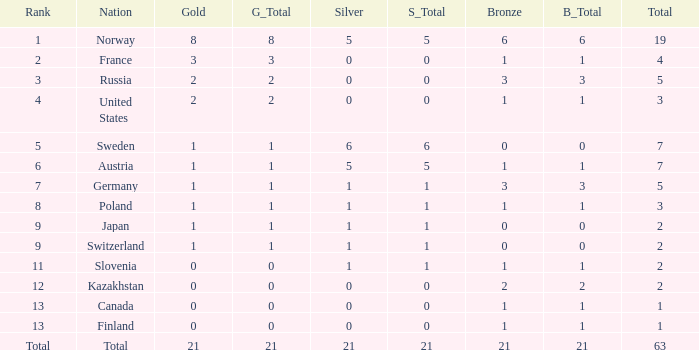What Rank has a gold smaller than 1, and a silver larger than 0? 11.0. Parse the full table. {'header': ['Rank', 'Nation', 'Gold', 'G_Total', 'Silver', 'S_Total', 'Bronze', 'B_Total', 'Total'], 'rows': [['1', 'Norway', '8', '8', '5', '5', '6', '6', '19'], ['2', 'France', '3', '3', '0', '0', '1', '1', '4'], ['3', 'Russia', '2', '2', '0', '0', '3', '3', '5'], ['4', 'United States', '2', '2', '0', '0', '1', '1', '3'], ['5', 'Sweden', '1', '1', '6', '6', '0', '0', '7'], ['6', 'Austria', '1', '1', '5', '5', '1', '1', '7'], ['7', 'Germany', '1', '1', '1', '1', '3', '3', '5'], ['8', 'Poland', '1', '1', '1', '1', '1', '1', '3'], ['9', 'Japan', '1', '1', '1', '1', '0', '0', '2'], ['9', 'Switzerland', '1', '1', '1', '1', '0', '0', '2'], ['11', 'Slovenia', '0', '0', '1', '1', '1', '1', '2'], ['12', 'Kazakhstan', '0', '0', '0', '0', '2', '2', '2'], ['13', 'Canada', '0', '0', '0', '0', '1', '1', '1'], ['13', 'Finland', '0', '0', '0', '0', '1', '1', '1'], ['Total', 'Total', '21', '21', '21', '21', '21', '21', '63']]} 